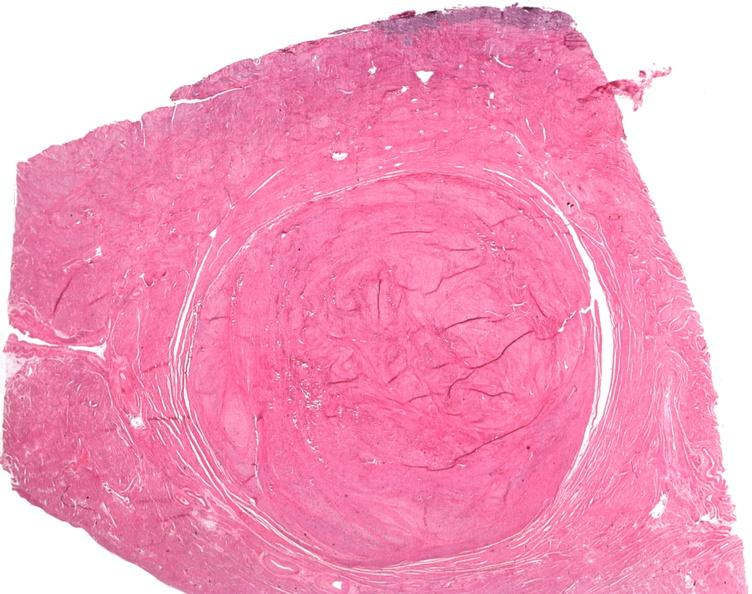does this image show uterus, leiomyoma?
Answer the question using a single word or phrase. Yes 